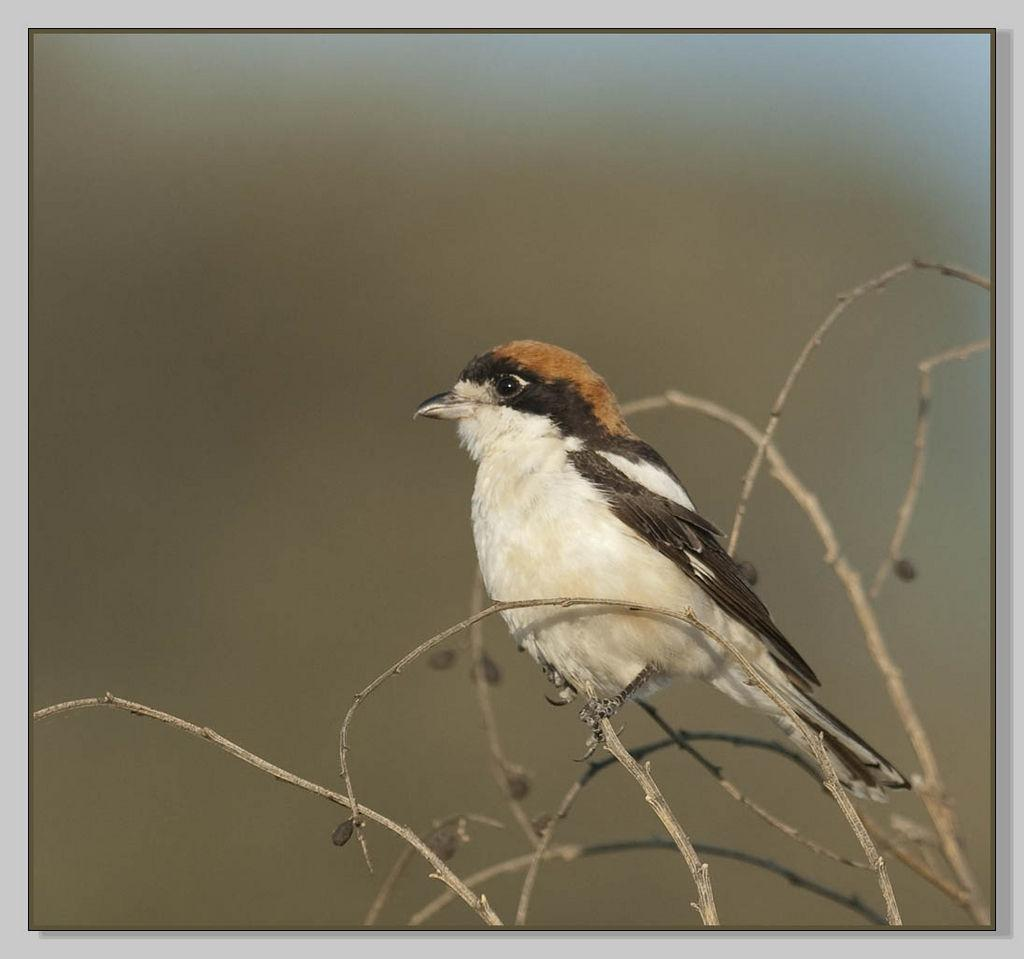What can be found in the image that resembles a plant? There are stems in the image. What type of animal is present in the image? There is a bird in the image. What colors make up the bird's color pattern? The bird has a color pattern of white, black, and brown. How would you describe the image's background? The image is blurry in the background. What type of winter clothing is the grandfather wearing in the image? There is no grandfather or winter clothing present in the image. 